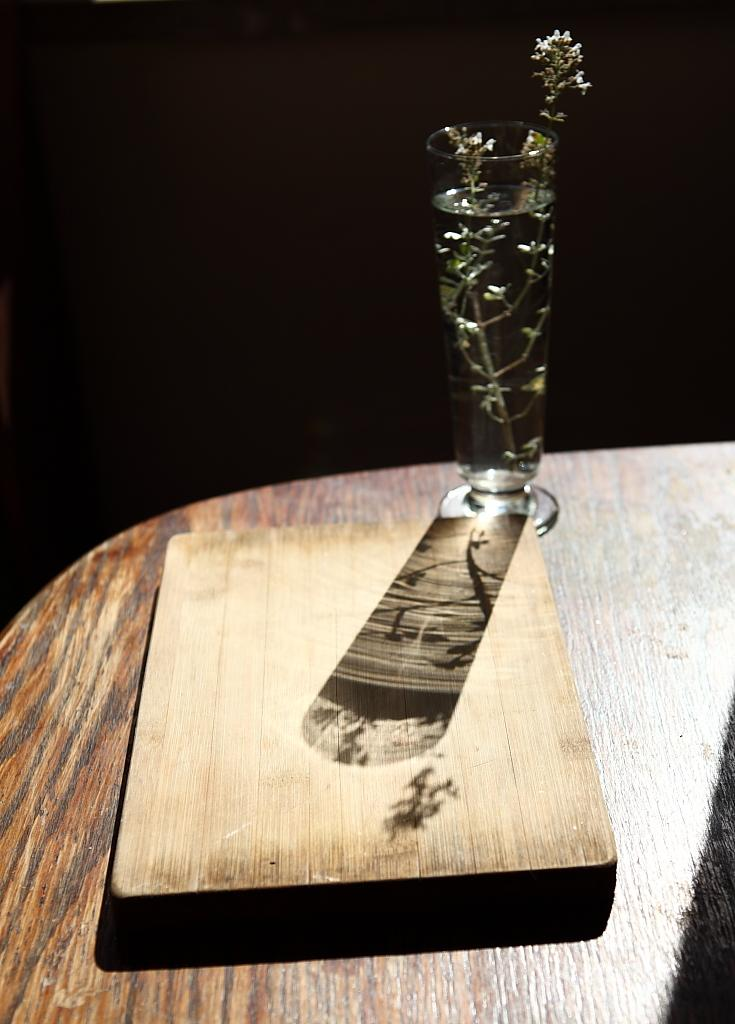What piece of furniture is present in the image? There is a table in the image. What is on top of the table? There is a flower vase and a wooden box on the table. What type of action is the sofa performing in the image? There is no sofa present in the image, so it cannot perform any actions. 